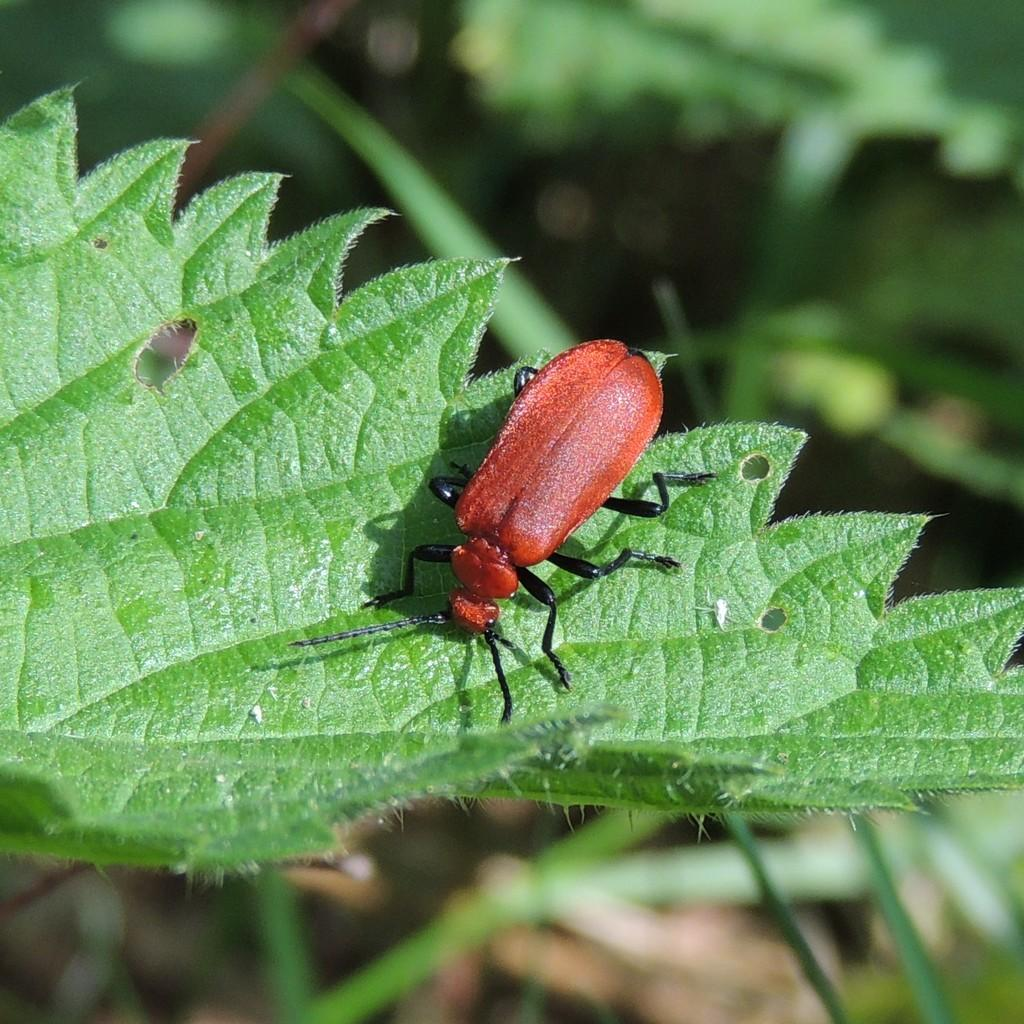What color is the insect in the image? The insect in the image is red. Where is the insect located in the image? The insect is sitting on a green leaf. What can be observed about the background of the image? The background of the image is blurred. Can you see the friend of the insect in the image? There is no friend of the insect present in the image. Is there a trail visible in the image? There is no trail visible in the image. 